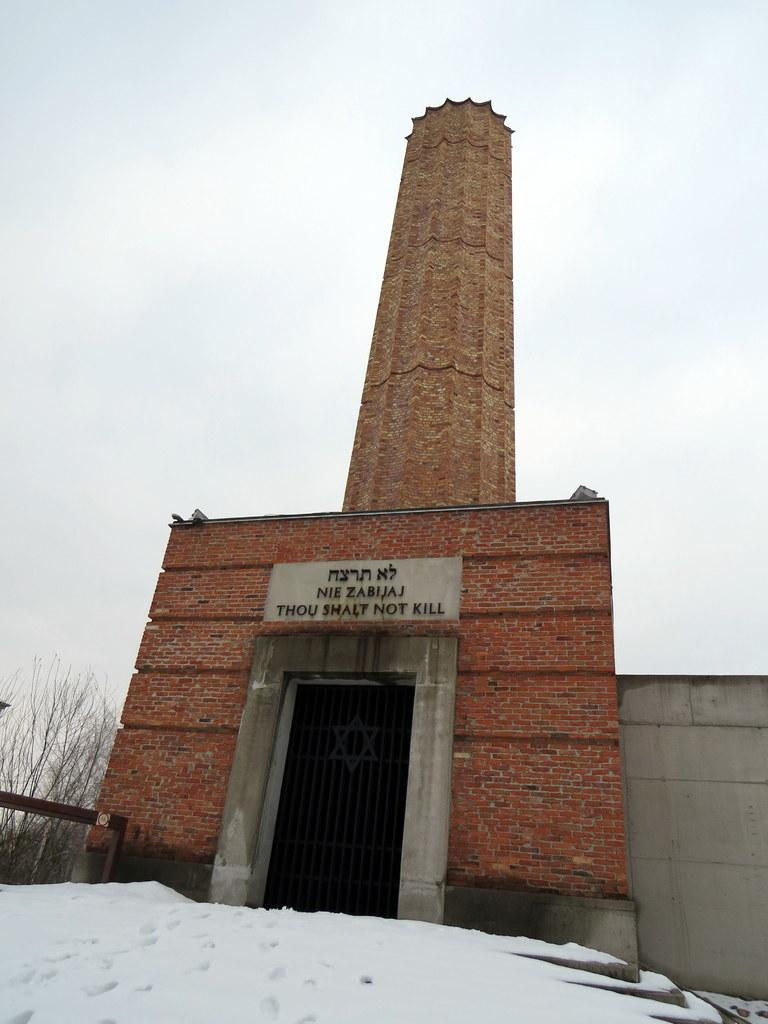What is the predominant color of the snow in the image? The snow in the image is white in color. What is the color of the building in the image? The building in the image is brown in color. What can be seen in the background of the image? There are trees and the sky visible in the background of the image. What type of surprise is hidden in the snow in the image? There is no indication of a surprise hidden in the snow in the image. Is there a bomb visible in the image? No, there is no bomb present in the image. 